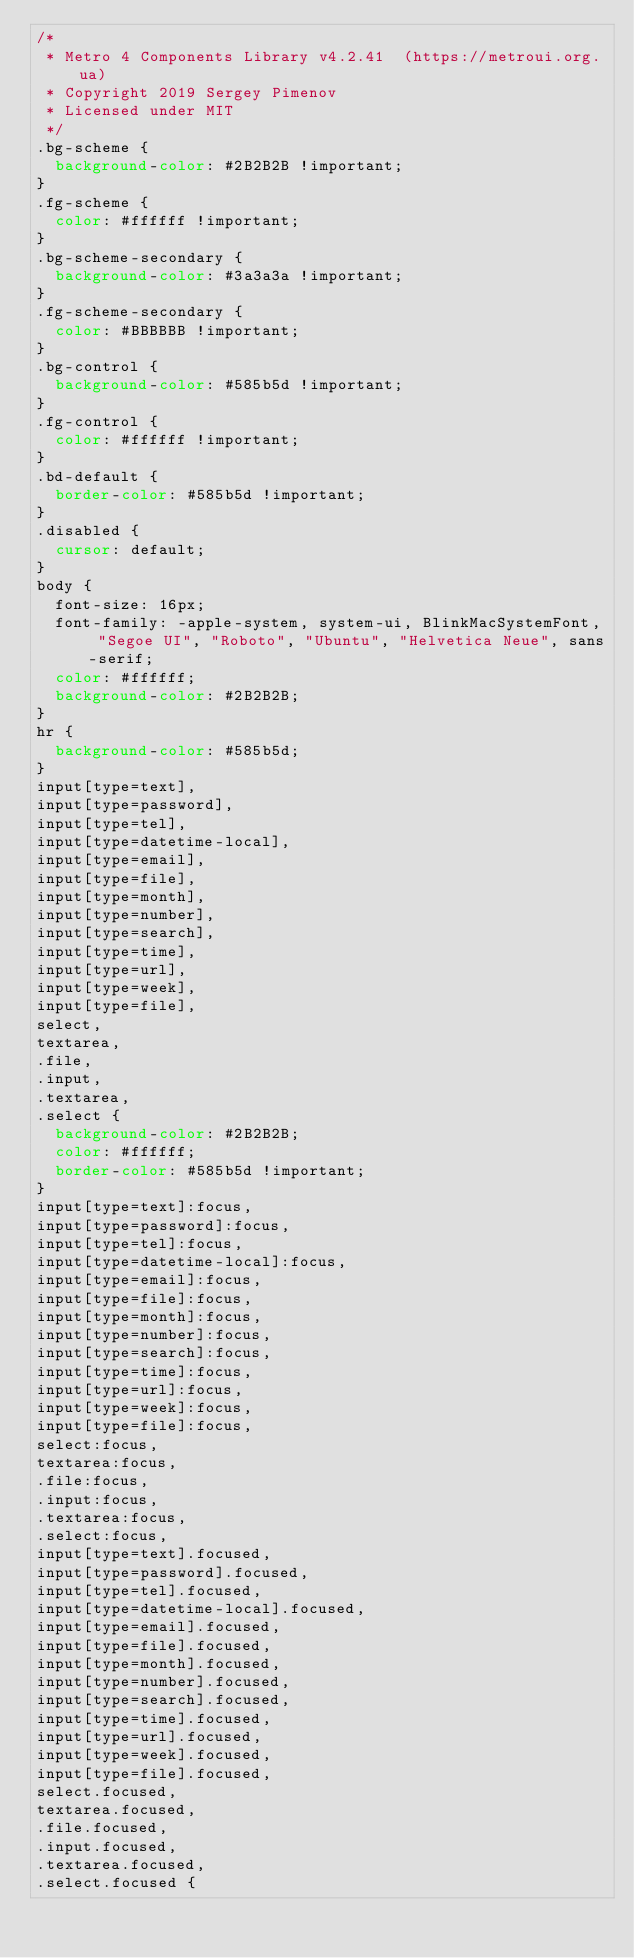Convert code to text. <code><loc_0><loc_0><loc_500><loc_500><_CSS_>/*
 * Metro 4 Components Library v4.2.41  (https://metroui.org.ua)
 * Copyright 2019 Sergey Pimenov
 * Licensed under MIT
 */
.bg-scheme {
  background-color: #2B2B2B !important;
}
.fg-scheme {
  color: #ffffff !important;
}
.bg-scheme-secondary {
  background-color: #3a3a3a !important;
}
.fg-scheme-secondary {
  color: #BBBBBB !important;
}
.bg-control {
  background-color: #585b5d !important;
}
.fg-control {
  color: #ffffff !important;
}
.bd-default {
  border-color: #585b5d !important;
}
.disabled {
  cursor: default;
}
body {
  font-size: 16px;
  font-family: -apple-system, system-ui, BlinkMacSystemFont, "Segoe UI", "Roboto", "Ubuntu", "Helvetica Neue", sans-serif;
  color: #ffffff;
  background-color: #2B2B2B;
}
hr {
  background-color: #585b5d;
}
input[type=text],
input[type=password],
input[type=tel],
input[type=datetime-local],
input[type=email],
input[type=file],
input[type=month],
input[type=number],
input[type=search],
input[type=time],
input[type=url],
input[type=week],
input[type=file],
select,
textarea,
.file,
.input,
.textarea,
.select {
  background-color: #2B2B2B;
  color: #ffffff;
  border-color: #585b5d !important;
}
input[type=text]:focus,
input[type=password]:focus,
input[type=tel]:focus,
input[type=datetime-local]:focus,
input[type=email]:focus,
input[type=file]:focus,
input[type=month]:focus,
input[type=number]:focus,
input[type=search]:focus,
input[type=time]:focus,
input[type=url]:focus,
input[type=week]:focus,
input[type=file]:focus,
select:focus,
textarea:focus,
.file:focus,
.input:focus,
.textarea:focus,
.select:focus,
input[type=text].focused,
input[type=password].focused,
input[type=tel].focused,
input[type=datetime-local].focused,
input[type=email].focused,
input[type=file].focused,
input[type=month].focused,
input[type=number].focused,
input[type=search].focused,
input[type=time].focused,
input[type=url].focused,
input[type=week].focused,
input[type=file].focused,
select.focused,
textarea.focused,
.file.focused,
.input.focused,
.textarea.focused,
.select.focused {</code> 